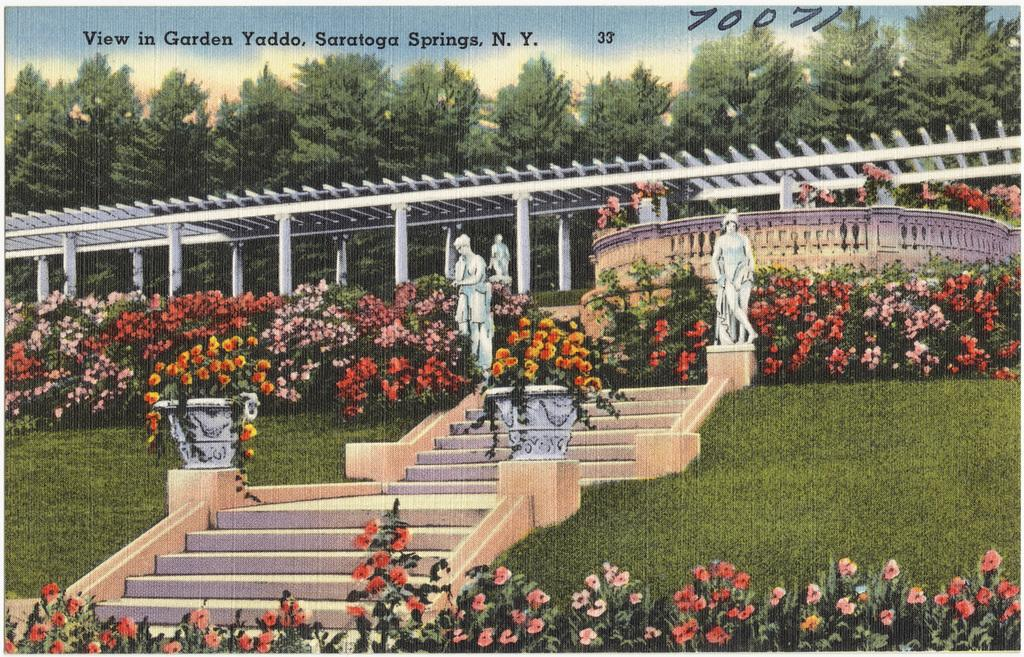<image>
Summarize the visual content of the image. The garden view with Saratoga Springs, NY at the top. 